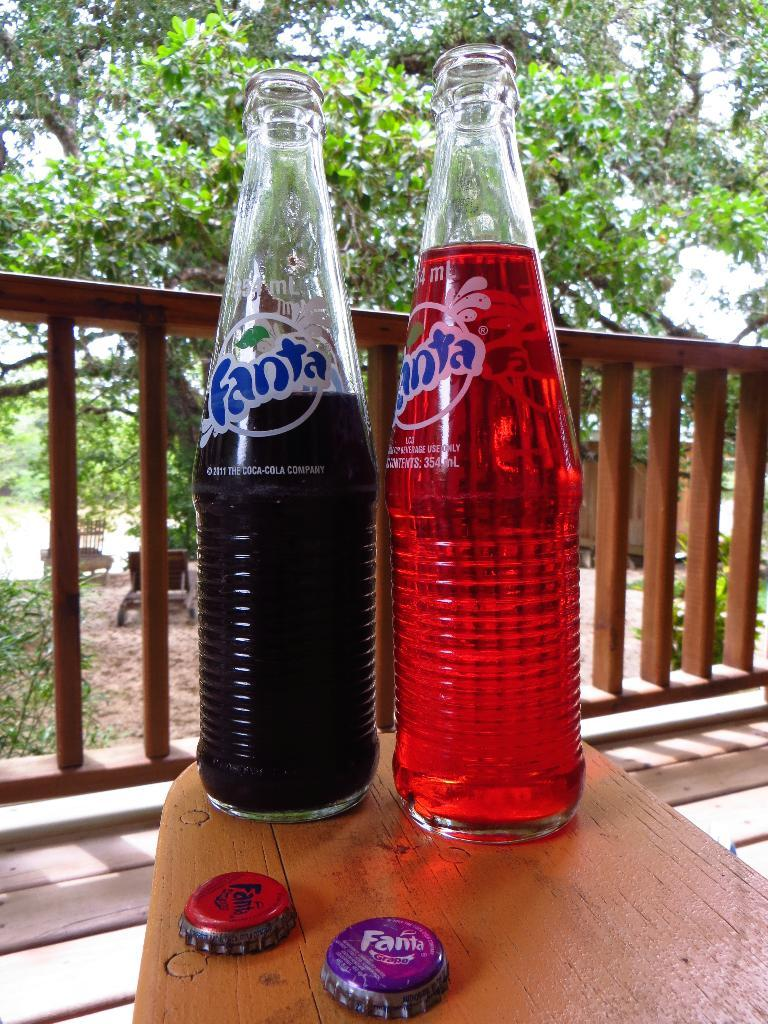Provide a one-sentence caption for the provided image. Two bottles of Fanta soda sitting on a table. 